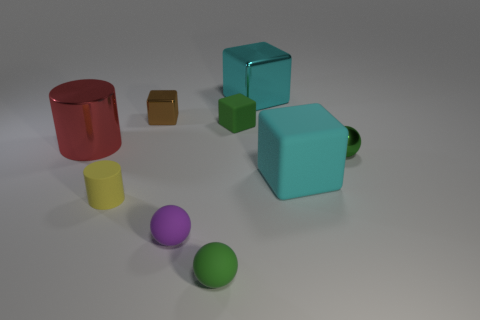There is a tiny matte cube; is it the same color as the ball that is behind the small yellow thing?
Give a very brief answer. Yes. Are there any other objects of the same color as the big rubber object?
Give a very brief answer. Yes. There is another cube that is the same color as the large shiny cube; what is it made of?
Your answer should be very brief. Rubber. What number of other objects are the same shape as the big red shiny object?
Offer a terse response. 1. Is the size of the brown metal thing the same as the green rubber object that is in front of the small matte block?
Make the answer very short. Yes. How many things are either cyan cubes that are behind the big red cylinder or tiny green matte cylinders?
Make the answer very short. 1. What is the shape of the green matte thing that is in front of the big cyan matte block?
Provide a succinct answer. Sphere. Is the number of brown blocks in front of the big red metal thing the same as the number of small cubes that are to the right of the purple matte ball?
Your answer should be compact. No. There is a small object that is in front of the small brown object and to the left of the purple object; what is its color?
Make the answer very short. Yellow. What material is the big cube that is left of the big cube right of the big cyan shiny block?
Provide a short and direct response. Metal. 